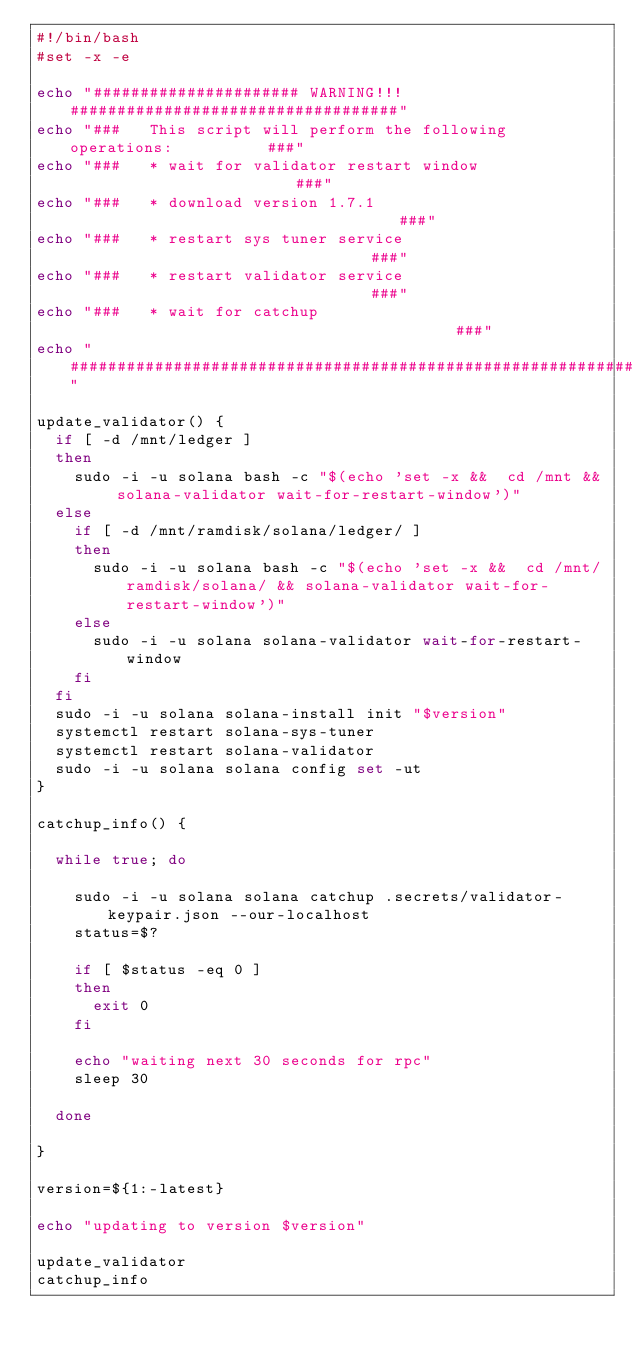Convert code to text. <code><loc_0><loc_0><loc_500><loc_500><_Bash_>#!/bin/bash
#set -x -e

echo "###################### WARNING!!! ###################################"
echo "###   This script will perform the following operations:          ###"
echo "###   * wait for validator restart window                         ###"
echo "###   * download version 1.7.1                                    ###"
echo "###   * restart sys tuner service                                 ###"
echo "###   * restart validator service                                 ###"
echo "###   * wait for catchup                                          ###"
echo "#####################################################################"

update_validator() {
  if [ -d /mnt/ledger ]
  then
    sudo -i -u solana bash -c "$(echo 'set -x &&  cd /mnt && solana-validator wait-for-restart-window')"
  else
    if [ -d /mnt/ramdisk/solana/ledger/ ]
    then
      sudo -i -u solana bash -c "$(echo 'set -x &&  cd /mnt/ramdisk/solana/ && solana-validator wait-for-restart-window')"
    else
      sudo -i -u solana solana-validator wait-for-restart-window
    fi
  fi
  sudo -i -u solana solana-install init "$version"
  systemctl restart solana-sys-tuner
  systemctl restart solana-validator
  sudo -i -u solana solana config set -ut
}

catchup_info() {

  while true; do

    sudo -i -u solana solana catchup .secrets/validator-keypair.json --our-localhost
    status=$?

    if [ $status -eq 0 ]
    then
      exit 0
    fi

    echo "waiting next 30 seconds for rpc"
    sleep 30

  done

}

version=${1:-latest}

echo "updating to version $version"

update_validator
catchup_info
</code> 